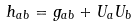<formula> <loc_0><loc_0><loc_500><loc_500>h _ { a b } = g _ { a b } + U _ { a } U _ { b }</formula> 